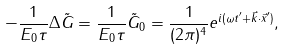Convert formula to latex. <formula><loc_0><loc_0><loc_500><loc_500>- \frac { 1 } { E _ { 0 } \tau } \Delta \tilde { G } = \frac { 1 } { E _ { 0 } \tau } \tilde { G } _ { 0 } = \frac { 1 } { ( 2 \pi ) ^ { 4 } } e ^ { i ( \omega t ^ { \prime } + \vec { k } \cdot \vec { x } ^ { \prime } ) } ,</formula> 